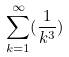<formula> <loc_0><loc_0><loc_500><loc_500>\sum _ { k = 1 } ^ { \infty } ( \frac { 1 } { k ^ { 3 } } )</formula> 